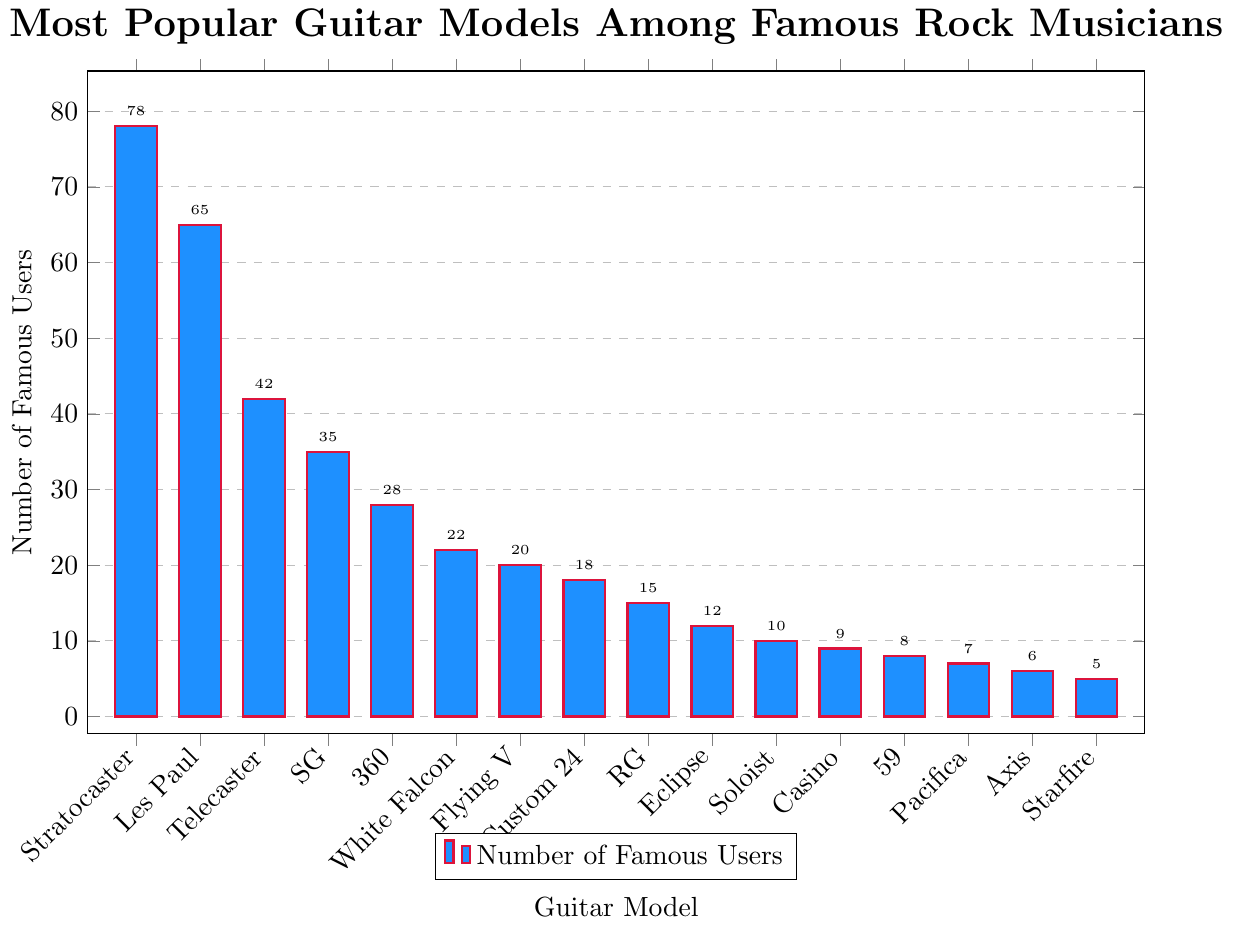Which guitar model is the most popular among famous rock musicians? By looking at the height of the bars, the "Stratocaster" has the highest bar, indicating it is the most popular model with 78 famous users.
Answer: Stratocaster How many more famous users does the Stratocaster have compared to the Les Paul? The Stratocaster has 78 famous users, while the Les Paul has 65. Subtracting these values gives 78 - 65.
Answer: 13 Which brand has the most models listed? By counting the different models associated with each brand, Gibson has the most models listed: Les Paul, SG, Flying V, and Casino.
Answer: Gibson What is the total number of famous users for Fender's guitar models? Summing the numbers for Fender's models: Stratocaster (78), Telecaster (42) results in 78 + 42.
Answer: 120 Which guitar model has the fewest famous users, and how many users does it have? The shortest bar on the chart represents the "Starfire" model, which has 5 famous users.
Answer: Starfire, 5 What is the difference in the number of users between the Telecaster and the SG? The Telecaster has 42 users, and the SG has 35 users. Subtracting these values gives 42 - 35.
Answer: 7 Among the models with less than 20 famous users, which one has the highest number of users? Filtering out the models with less than 20 users, the highest number of users is for the "Custom 24" with 18 users.
Answer: Custom 24 How many guitar models have more than 30 famous users? By counting the models with more than 30 users: Stratocaster (78), Les Paul (65), Telecaster (42), SG (35), and 360 (28, which is not more than 30), we get four models.
Answer: 4 What is the average number of famous users for the models "RG," "Eclipse," and "Soloist"? Adding the number of users for these models: RG (15), Eclipse (12), Soloist (10) and dividing by 3 results in (15 + 12 + 10) / 3.
Answer: 12.33 